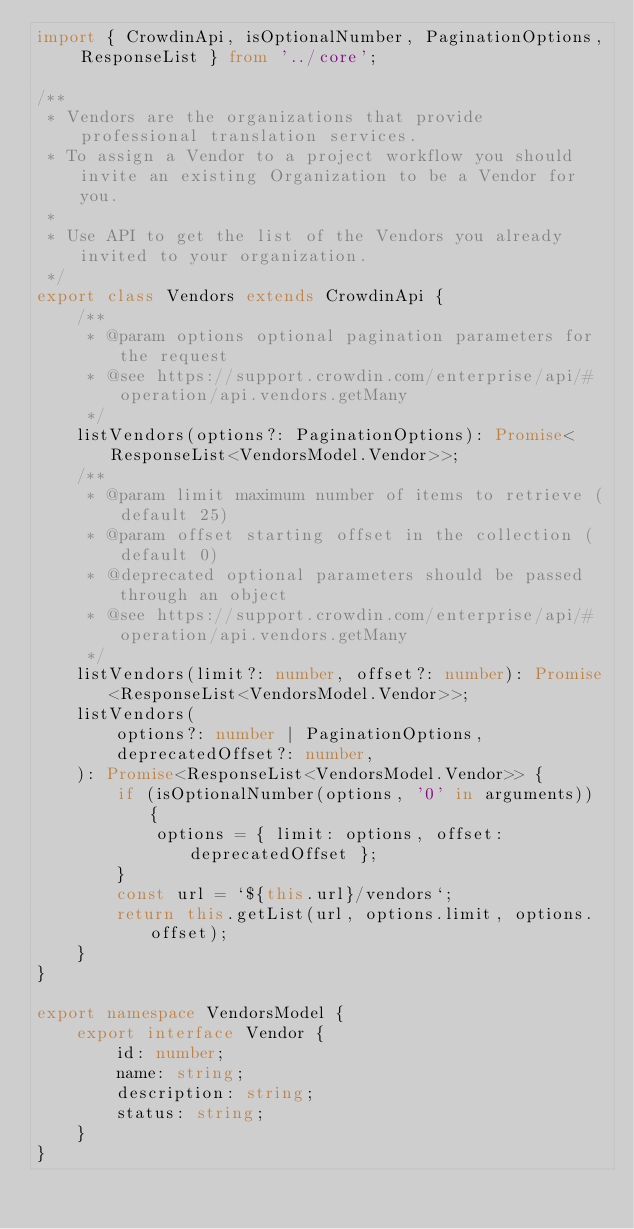<code> <loc_0><loc_0><loc_500><loc_500><_TypeScript_>import { CrowdinApi, isOptionalNumber, PaginationOptions, ResponseList } from '../core';

/**
 * Vendors are the organizations that provide professional translation services.
 * To assign a Vendor to a project workflow you should invite an existing Organization to be a Vendor for you.
 *
 * Use API to get the list of the Vendors you already invited to your organization.
 */
export class Vendors extends CrowdinApi {
    /**
     * @param options optional pagination parameters for the request
     * @see https://support.crowdin.com/enterprise/api/#operation/api.vendors.getMany
     */
    listVendors(options?: PaginationOptions): Promise<ResponseList<VendorsModel.Vendor>>;
    /**
     * @param limit maximum number of items to retrieve (default 25)
     * @param offset starting offset in the collection (default 0)
     * @deprecated optional parameters should be passed through an object
     * @see https://support.crowdin.com/enterprise/api/#operation/api.vendors.getMany
     */
    listVendors(limit?: number, offset?: number): Promise<ResponseList<VendorsModel.Vendor>>;
    listVendors(
        options?: number | PaginationOptions,
        deprecatedOffset?: number,
    ): Promise<ResponseList<VendorsModel.Vendor>> {
        if (isOptionalNumber(options, '0' in arguments)) {
            options = { limit: options, offset: deprecatedOffset };
        }
        const url = `${this.url}/vendors`;
        return this.getList(url, options.limit, options.offset);
    }
}

export namespace VendorsModel {
    export interface Vendor {
        id: number;
        name: string;
        description: string;
        status: string;
    }
}
</code> 